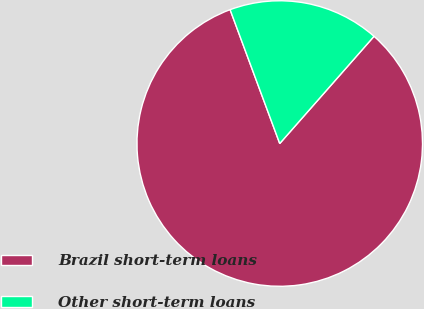<chart> <loc_0><loc_0><loc_500><loc_500><pie_chart><fcel>Brazil short-term loans<fcel>Other short-term loans<nl><fcel>82.87%<fcel>17.13%<nl></chart> 